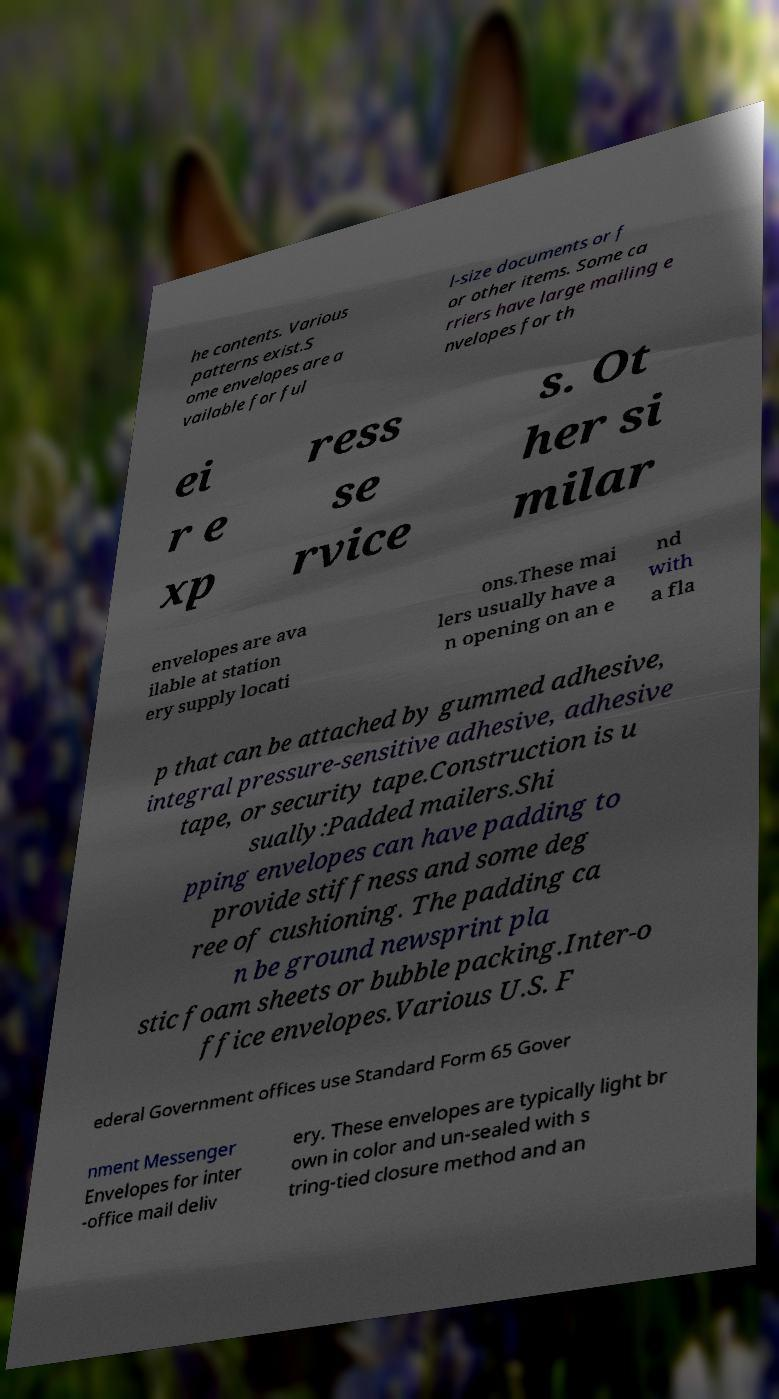Please read and relay the text visible in this image. What does it say? he contents. Various patterns exist.S ome envelopes are a vailable for ful l-size documents or f or other items. Some ca rriers have large mailing e nvelopes for th ei r e xp ress se rvice s. Ot her si milar envelopes are ava ilable at station ery supply locati ons.These mai lers usually have a n opening on an e nd with a fla p that can be attached by gummed adhesive, integral pressure-sensitive adhesive, adhesive tape, or security tape.Construction is u sually:Padded mailers.Shi pping envelopes can have padding to provide stiffness and some deg ree of cushioning. The padding ca n be ground newsprint pla stic foam sheets or bubble packing.Inter-o ffice envelopes.Various U.S. F ederal Government offices use Standard Form 65 Gover nment Messenger Envelopes for inter -office mail deliv ery. These envelopes are typically light br own in color and un-sealed with s tring-tied closure method and an 